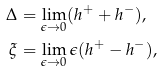Convert formula to latex. <formula><loc_0><loc_0><loc_500><loc_500>\Delta & = \lim _ { \epsilon \rightarrow 0 } ( h ^ { + } + h ^ { - } ) , \\ \xi & = \lim _ { \epsilon \rightarrow 0 } \epsilon ( h ^ { + } - h ^ { - } ) ,</formula> 